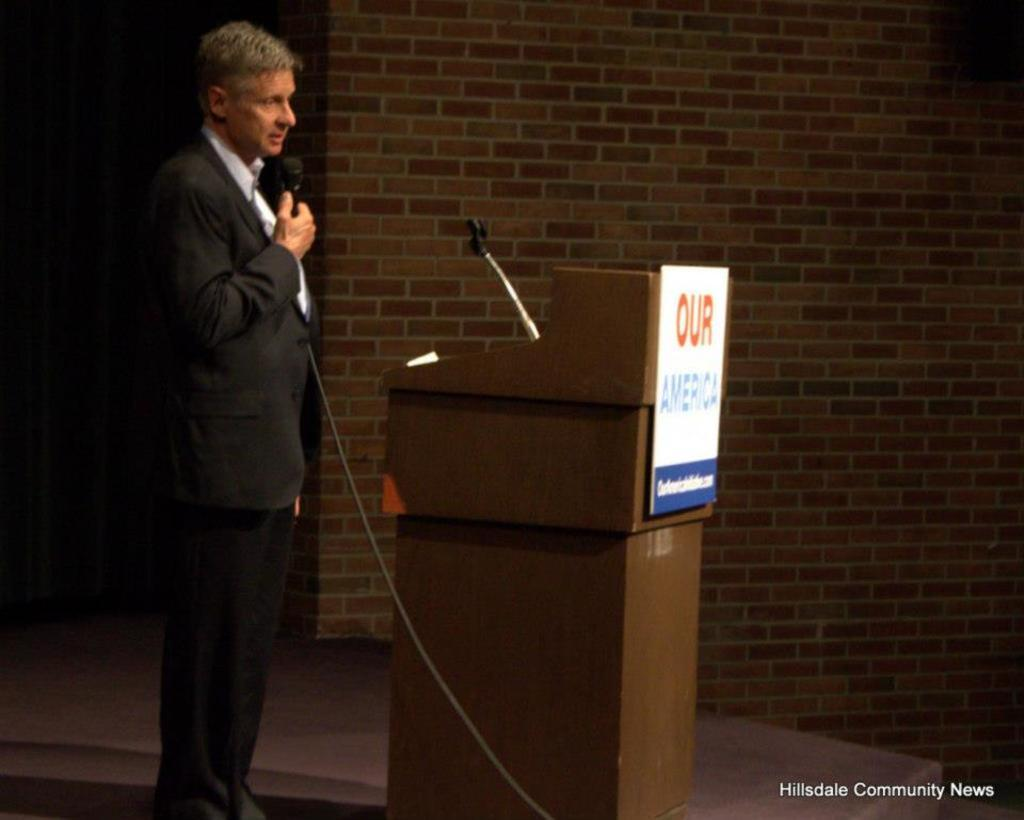<image>
Provide a brief description of the given image. a man at a microphone with an Our America sign next to him 